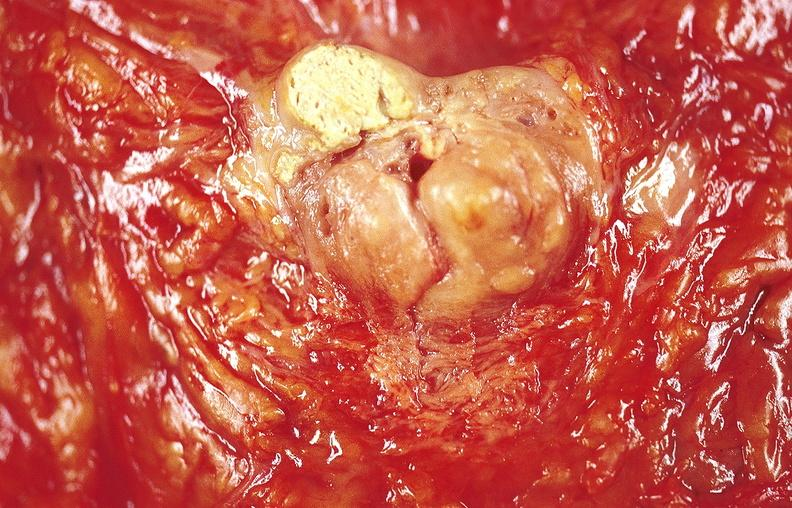s gastrointestinal present?
Answer the question using a single word or phrase. Yes 